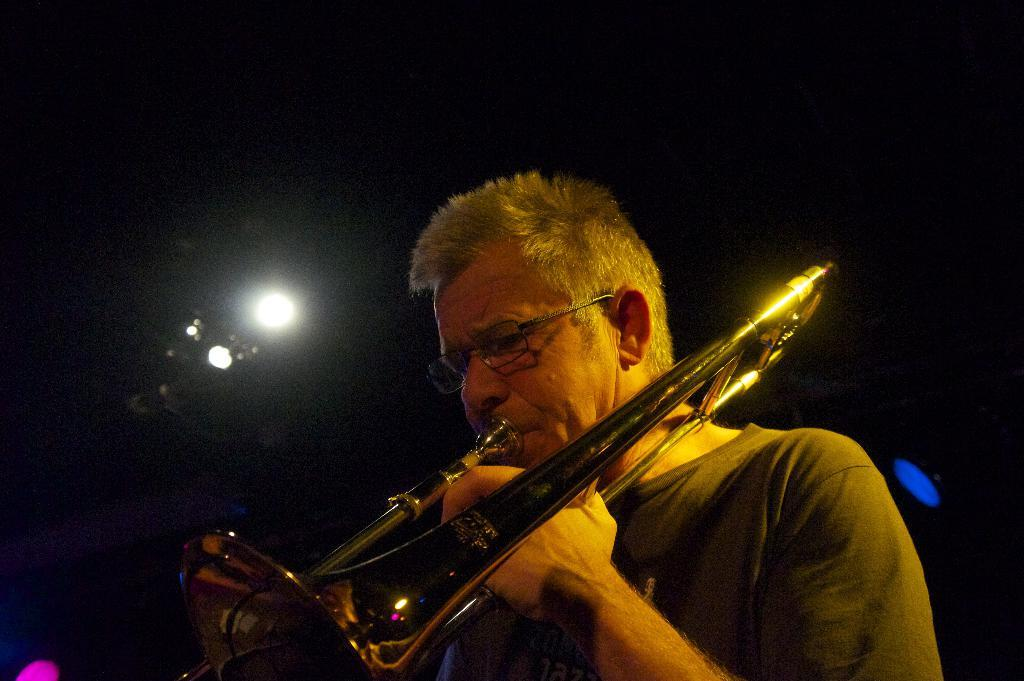Who is the main subject in the image? There is a man in the image. What is the man wearing? The man is wearing a T-shirt. What is the man doing in the image? The man is playing a trombone. What can be seen in the background of the image? There is a light in the background of the image. How would you describe the overall lighting in the image? The background of the image is dark. What type of cream is being used to paint the man's jeans in the image? There is no cream or painting activity present in the image. The man is wearing a T-shirt, not jeans, and there is no mention of cream or painting. 